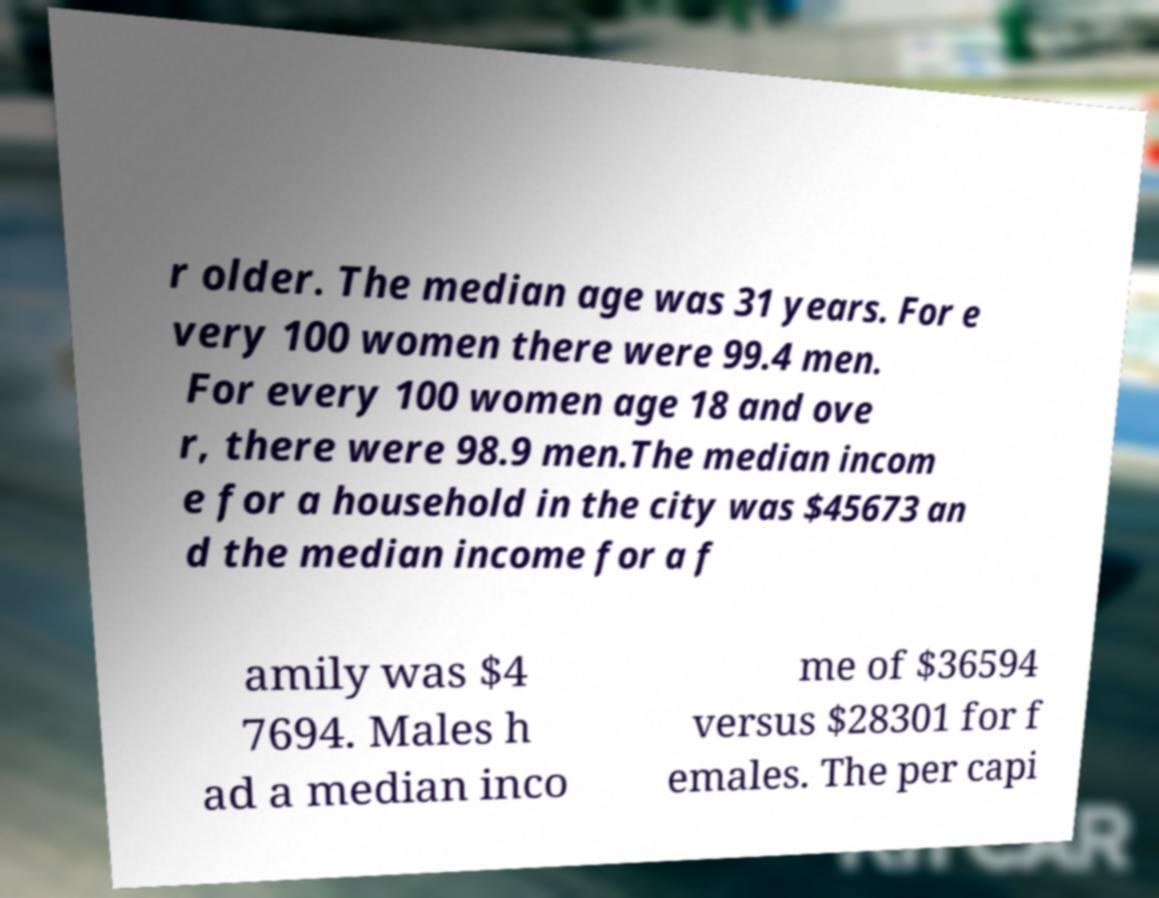Please identify and transcribe the text found in this image. r older. The median age was 31 years. For e very 100 women there were 99.4 men. For every 100 women age 18 and ove r, there were 98.9 men.The median incom e for a household in the city was $45673 an d the median income for a f amily was $4 7694. Males h ad a median inco me of $36594 versus $28301 for f emales. The per capi 